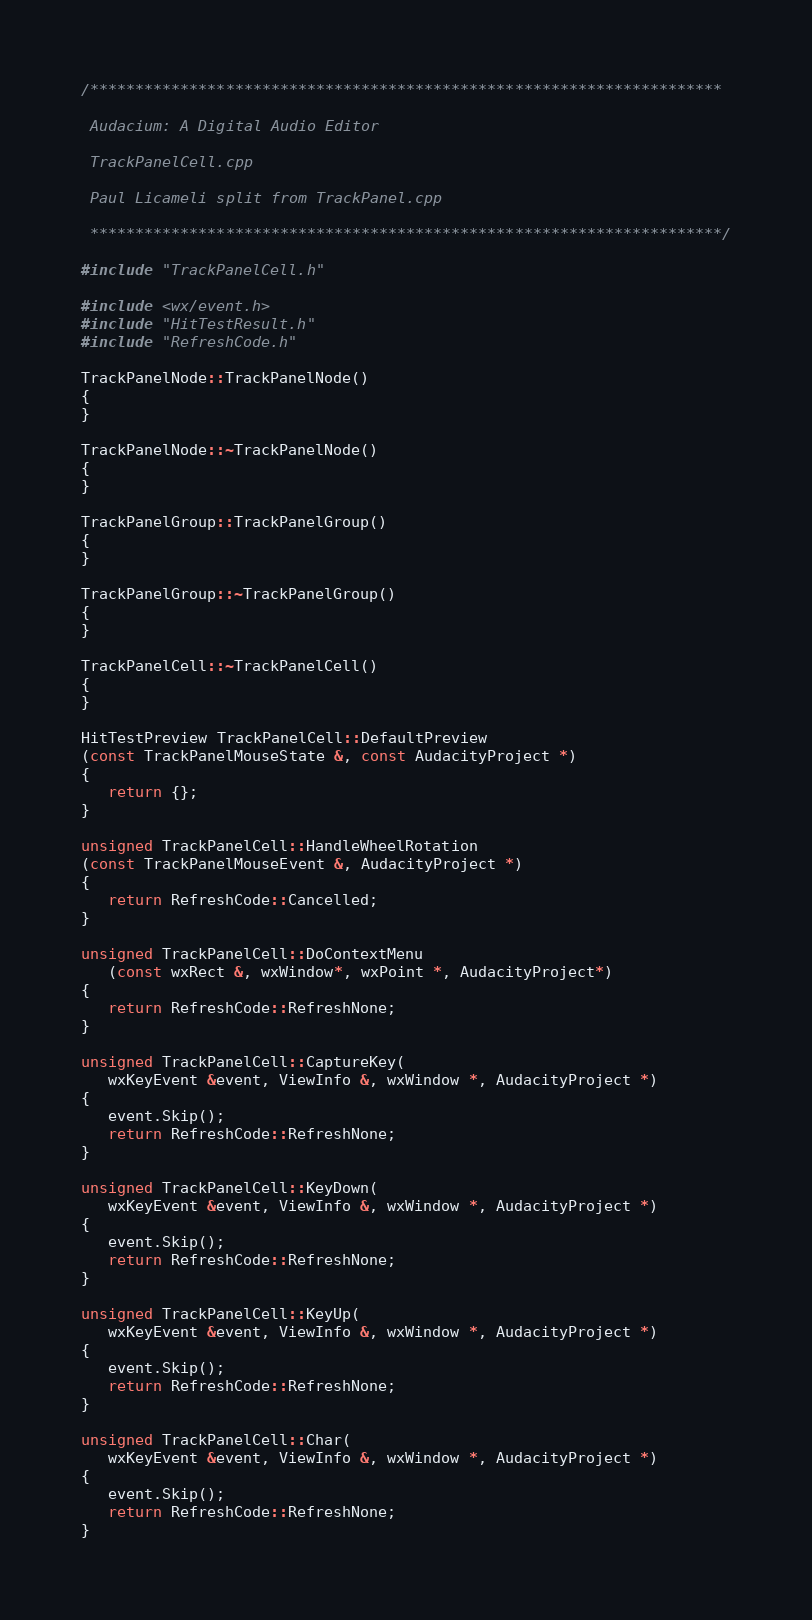<code> <loc_0><loc_0><loc_500><loc_500><_C++_>/**********************************************************************
 
 Audacium: A Digital Audio Editor
 
 TrackPanelCell.cpp
 
 Paul Licameli split from TrackPanel.cpp
 
 **********************************************************************/

#include "TrackPanelCell.h"

#include <wx/event.h>
#include "HitTestResult.h"
#include "RefreshCode.h"

TrackPanelNode::TrackPanelNode()
{
}

TrackPanelNode::~TrackPanelNode()
{
}

TrackPanelGroup::TrackPanelGroup()
{
}

TrackPanelGroup::~TrackPanelGroup()
{
}

TrackPanelCell::~TrackPanelCell()
{
}

HitTestPreview TrackPanelCell::DefaultPreview
(const TrackPanelMouseState &, const AudacityProject *)
{
   return {};
}

unsigned TrackPanelCell::HandleWheelRotation
(const TrackPanelMouseEvent &, AudacityProject *)
{
   return RefreshCode::Cancelled;
}

unsigned TrackPanelCell::DoContextMenu
   (const wxRect &, wxWindow*, wxPoint *, AudacityProject*)
{
   return RefreshCode::RefreshNone;
}

unsigned TrackPanelCell::CaptureKey(
   wxKeyEvent &event, ViewInfo &, wxWindow *, AudacityProject *)
{
   event.Skip();
   return RefreshCode::RefreshNone;
}

unsigned TrackPanelCell::KeyDown(
   wxKeyEvent &event, ViewInfo &, wxWindow *, AudacityProject *)
{
   event.Skip();
   return RefreshCode::RefreshNone;
}

unsigned TrackPanelCell::KeyUp(
   wxKeyEvent &event, ViewInfo &, wxWindow *, AudacityProject *)
{
   event.Skip();
   return RefreshCode::RefreshNone;
}

unsigned TrackPanelCell::Char(
   wxKeyEvent &event, ViewInfo &, wxWindow *, AudacityProject *)
{
   event.Skip();
   return RefreshCode::RefreshNone;
}
</code> 